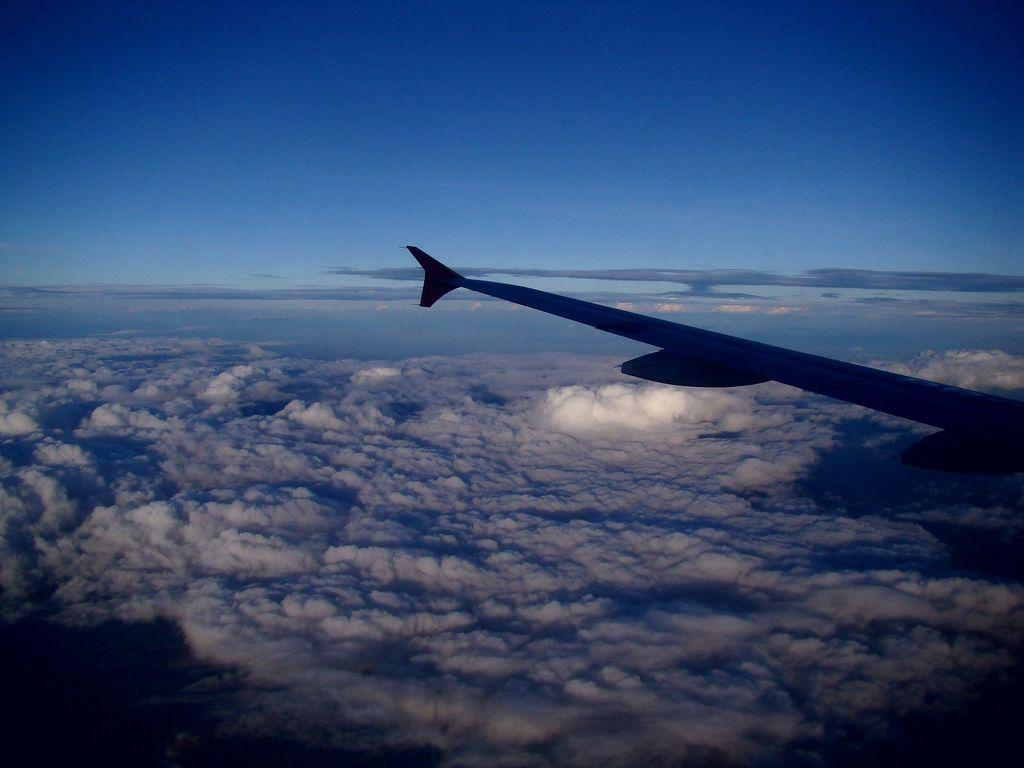What is located on the right side of the image? There is a wing of a plane on the right side of the image. What can be seen in the background of the image? The sky is visible in the background of the image. What type of natural formation can be observed in the sky? Clouds are present in the background of the image. What type of egg is being used as a toy for the doll in the image? There is no egg or doll present in the image; it only features a wing of a plane and the sky with clouds. 